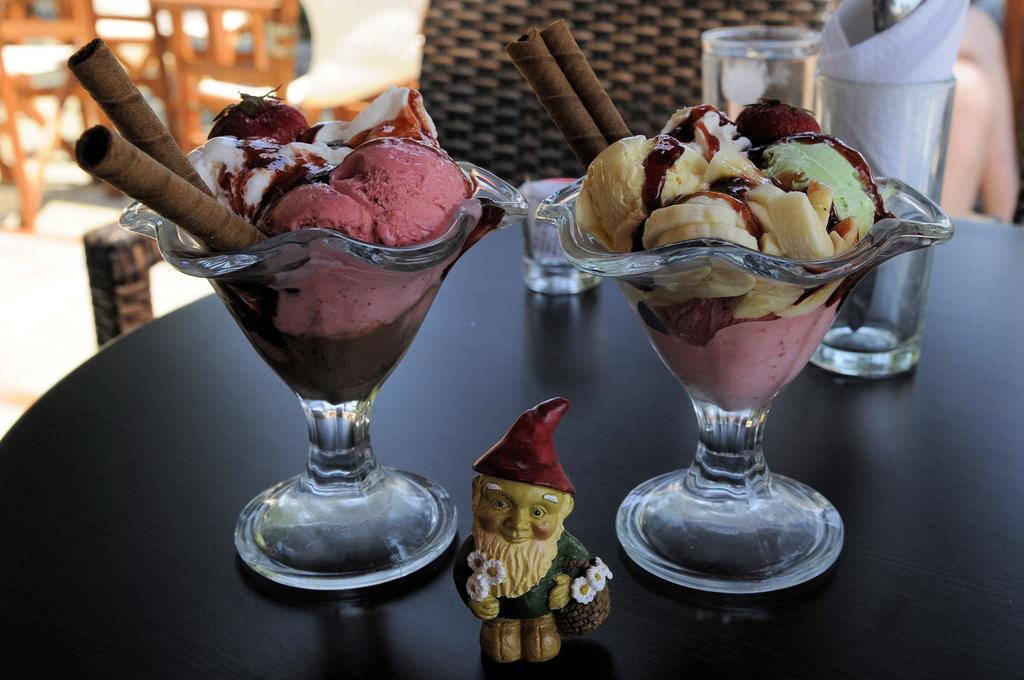What piece of furniture is present in the image? There is a table in the image. What objects are placed on the table? There are glasses, tissues, and ice creams on the table. Are there any seating options visible in the image? Yes, there are chairs behind the table. What type of potato is being served on the table in the image? There is no potato present in the image; the table has glasses, tissues, and ice creams. What is the rate of growth for the plants in the field visible in the image? There is no field visible in the image; the focus is on the table and its contents. 